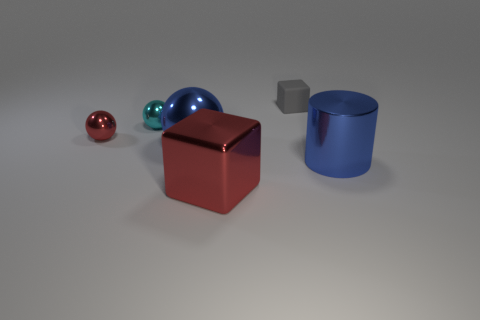What is the material of the small gray block that is on the right side of the blue shiny object behind the metallic thing that is on the right side of the big red metallic object?
Provide a succinct answer. Rubber. Do the red shiny ball and the matte cube on the right side of the tiny cyan shiny ball have the same size?
Make the answer very short. Yes. There is a small object that is the same shape as the large red shiny object; what is its material?
Keep it short and to the point. Rubber. How big is the cube in front of the small gray matte object that is left of the thing on the right side of the tiny block?
Make the answer very short. Large. Do the cyan ball and the rubber cube have the same size?
Offer a terse response. Yes. What material is the cube that is behind the red object left of the small cyan sphere made of?
Keep it short and to the point. Rubber. Does the blue object on the left side of the gray rubber block have the same shape as the red shiny thing behind the large shiny ball?
Give a very brief answer. Yes. Is the number of big blue metal objects on the left side of the tiny cube the same as the number of big red things?
Keep it short and to the point. Yes. Is there a blue ball in front of the small thing in front of the cyan metallic sphere?
Provide a short and direct response. Yes. Is there any other thing that has the same color as the large metallic ball?
Keep it short and to the point. Yes. 